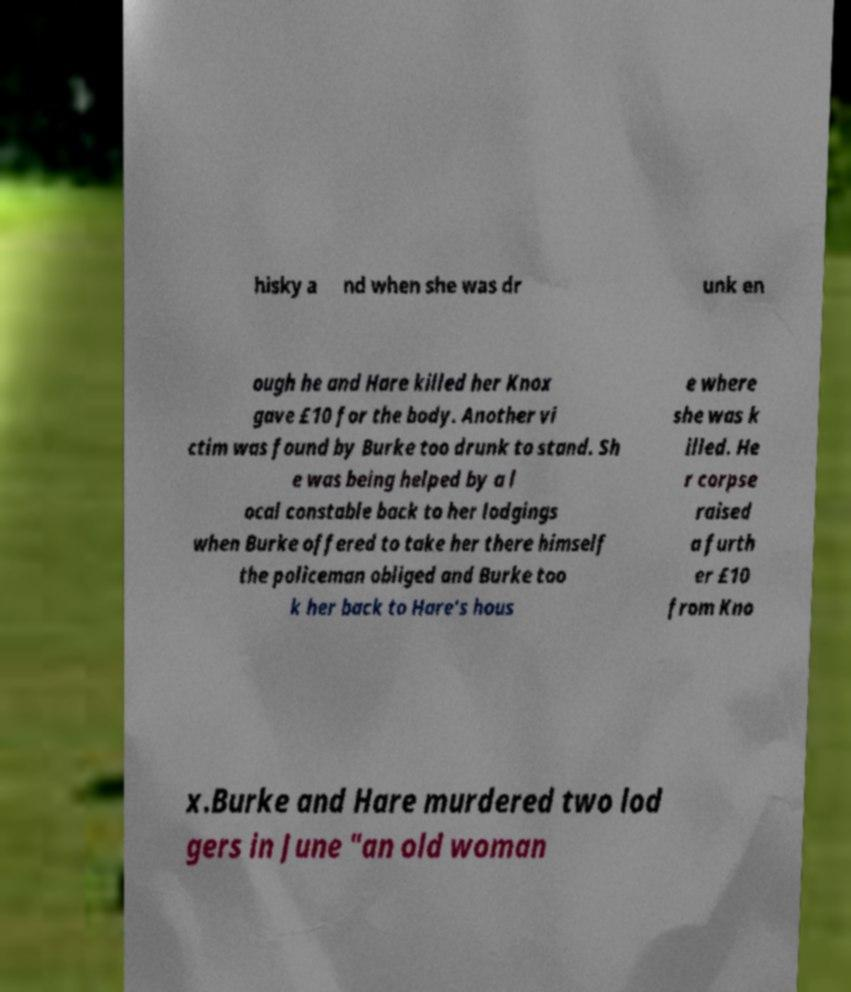Please read and relay the text visible in this image. What does it say? hisky a nd when she was dr unk en ough he and Hare killed her Knox gave £10 for the body. Another vi ctim was found by Burke too drunk to stand. Sh e was being helped by a l ocal constable back to her lodgings when Burke offered to take her there himself the policeman obliged and Burke too k her back to Hare's hous e where she was k illed. He r corpse raised a furth er £10 from Kno x.Burke and Hare murdered two lod gers in June "an old woman 